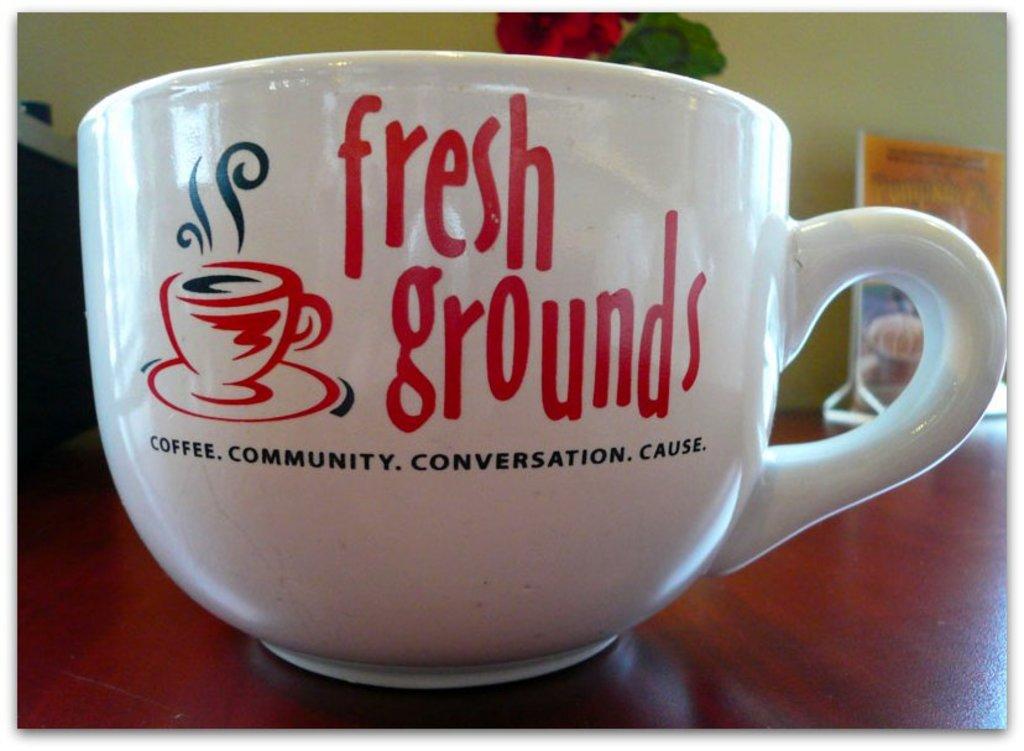What is the name of the company logo located on the coffee mug?
Ensure brevity in your answer.  Fresh grounds. What type of beverage does this cafe serve?
Offer a terse response. Coffee. 